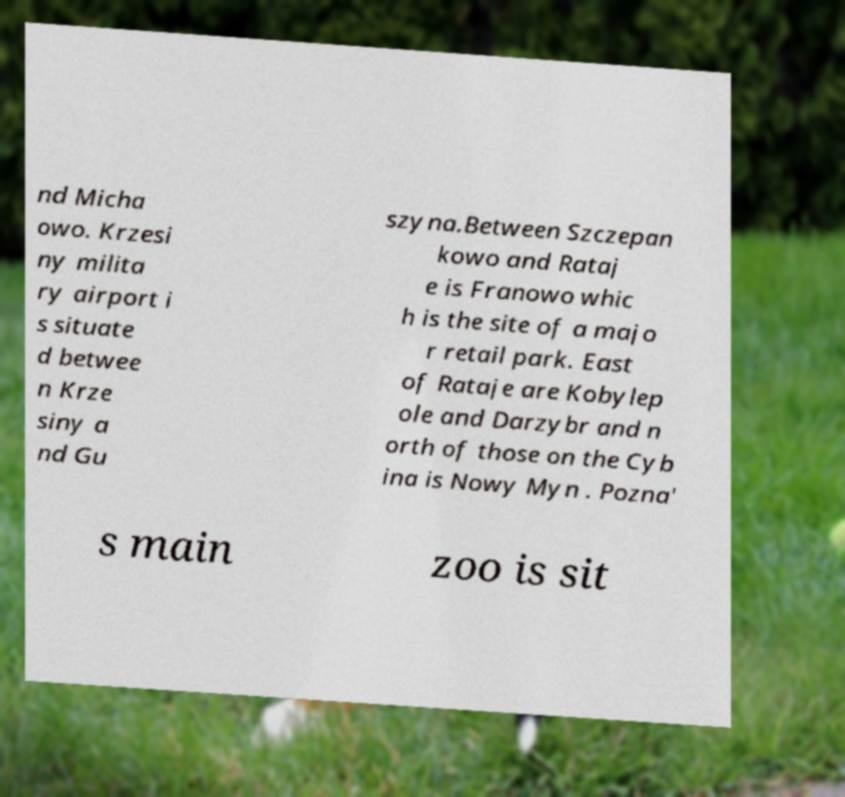For documentation purposes, I need the text within this image transcribed. Could you provide that? nd Micha owo. Krzesi ny milita ry airport i s situate d betwee n Krze siny a nd Gu szyna.Between Szczepan kowo and Rataj e is Franowo whic h is the site of a majo r retail park. East of Rataje are Kobylep ole and Darzybr and n orth of those on the Cyb ina is Nowy Myn . Pozna' s main zoo is sit 